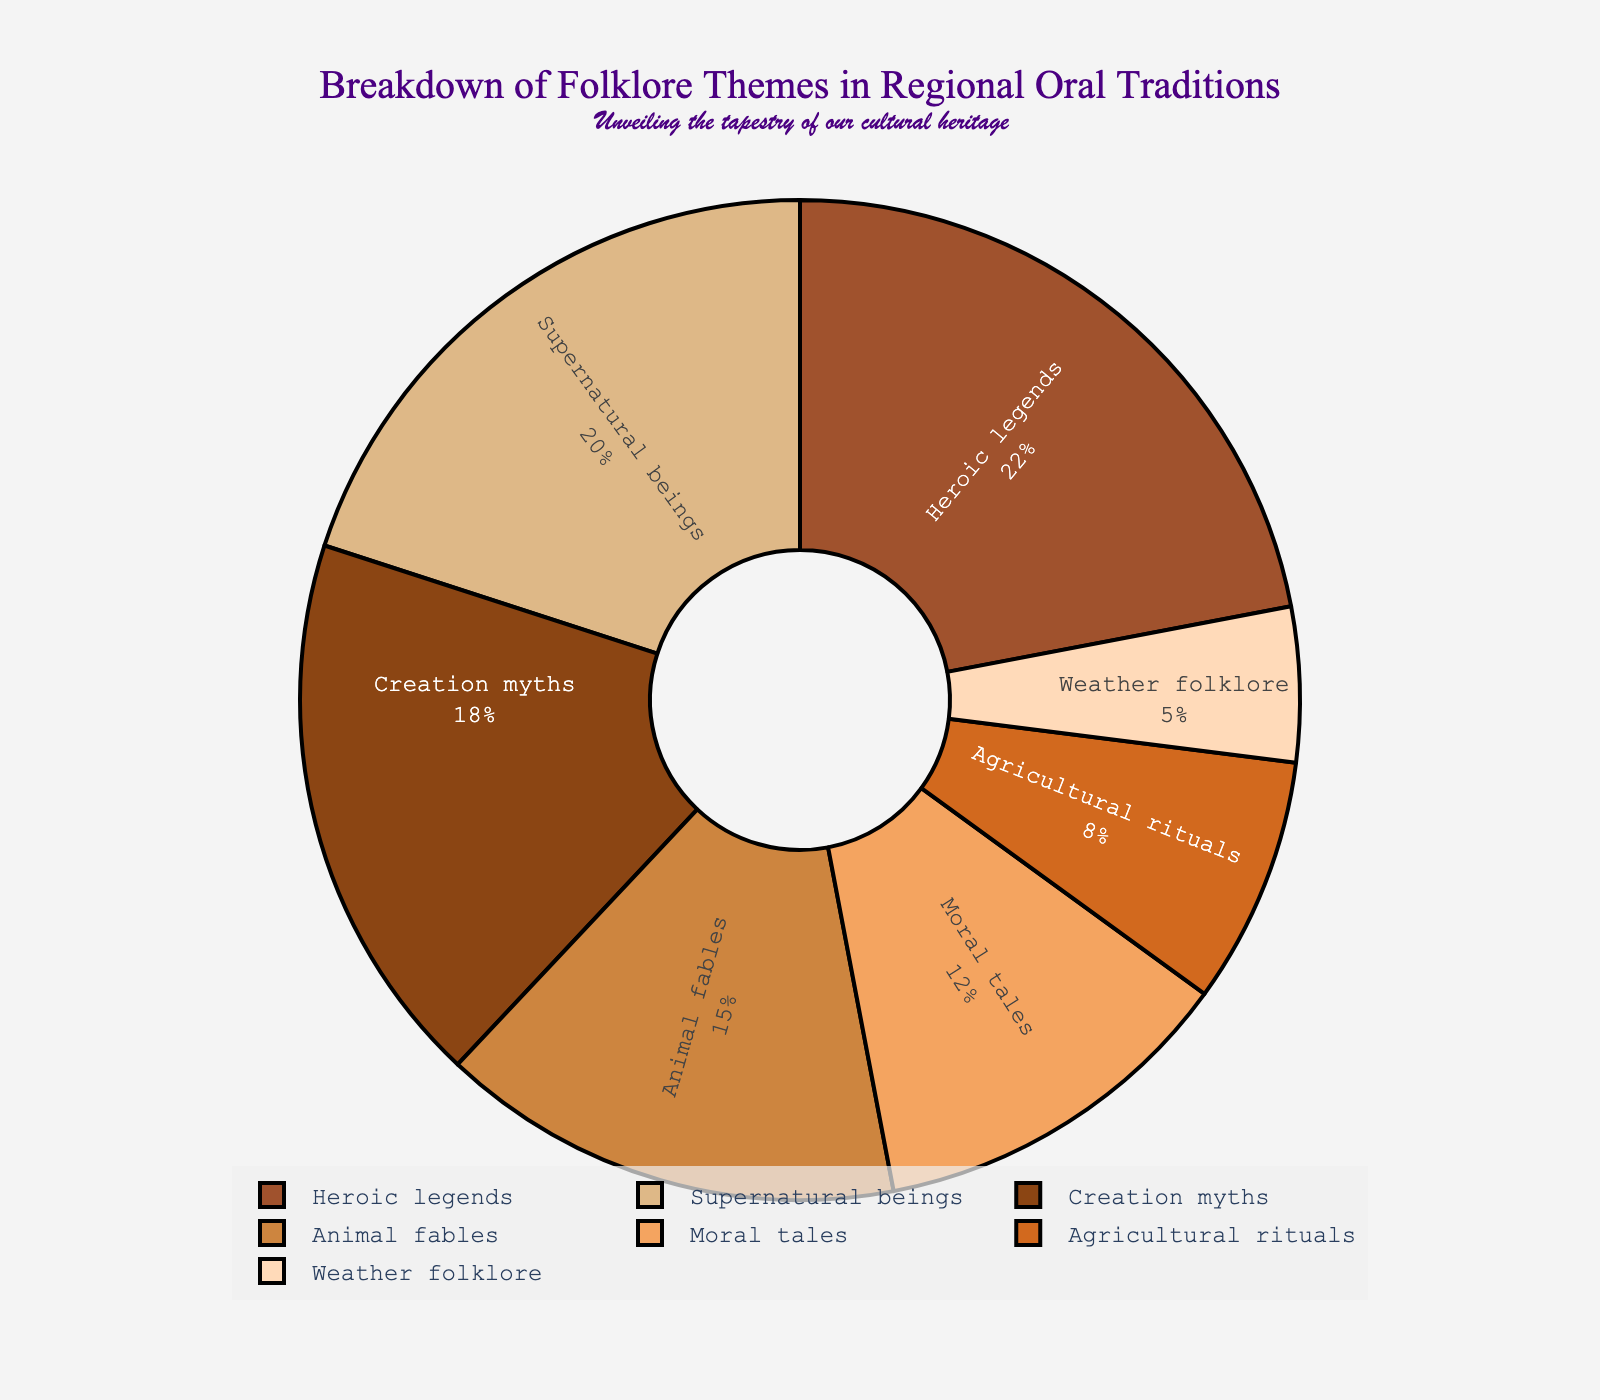What's the most prevalent folklore theme in the region's oral traditions? The pie chart shows several folklore themes with different percentages. The Heroic legends slice is the largest, accounting for 22% of the total, making it the most prevalent theme.
Answer: Heroic legends What is the combined percentage of Creation myths and Animal fables? The Creation myths slice represents 18%, and Animal fables represent 15%. Adding these two percentages together gives: 18% + 15% = 33%.
Answer: 33% Which theme is just slightly less represented than Supernatural beings? The Supernatural beings theme accounts for 20%. The next largest slice is Creation myths, which is 18%, slightly less represented.
Answer: Creation myths What are the themes represented by the lightest and the darkest colors in the pie chart? The lightest color is likely the Weather folklore slice, distinguished by its smaller size and paler shade, accounting for 5%. The darkest color is the Heroic legends slice, considering it is the largest slice and hence emphasized.
Answer: Weather folklore and Heroic legends How many themes have a percentage greater than 15%? By inspecting the pie chart, the themes with percentages greater than 15% are Creation myths (18%), Heroic legends (22%), Supernatural beings (20%), and Animal fables (15%). According to the criteria, only Creation myths, Heroic legends, and Supernatural beings exceed 15%.
Answer: 3 What is the average percentage of Agricultural rituals and Weather folklore? The Agricultural rituals slice is 8%, and Weather folklore is 5%. The average is calculated by adding these two percentages and dividing by 2: (8% + 5%) / 2 = 6.5%.
Answer: 6.5% Is the percentage of Moral tales greater than twice that of Weather folklore? The percentage of Moral tales is 12%, while Weather folklore accounts for 5%. Doubling the percentage of Weather folklore gives 5% * 2 = 10%. Since 12% is greater than 10%, the percentage of Moral tales is indeed greater than twice that of Weather folklore.
Answer: Yes Does the theme with the smallest percentage represent more than half the percentage of Creation myths? The theme with the smallest percentage is Weather folklore, at 5%. Half of the percentage of Creation myths is 18% / 2 = 9%. Since 5% is less than 9%, it does not represent more than half.
Answer: No What is the sum of the percentages of all the themes directly related to nature? The themes directly related to nature are Animal fables (15%), Agricultural rituals (8%), and Weather folklore (5%). Adding these gives: 15% + 8% + 5% = 28%.
Answer: 28% 